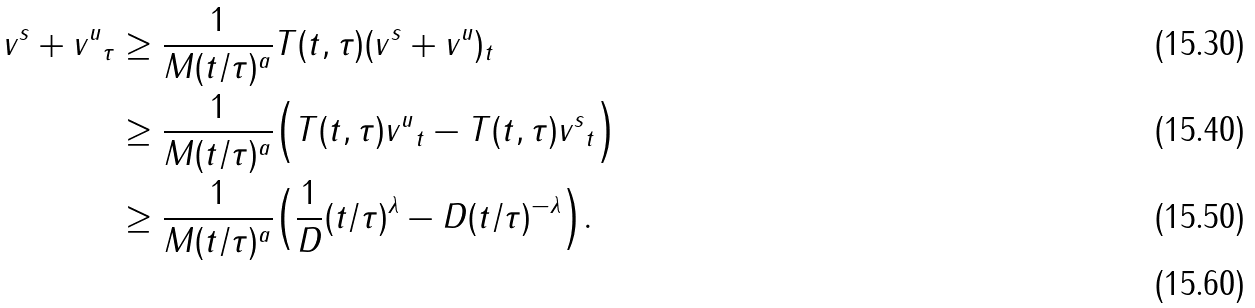<formula> <loc_0><loc_0><loc_500><loc_500>\| v ^ { s } + v ^ { u } \| _ { \tau } & \geq \frac { 1 } { M ( t / \tau ) ^ { a } } \| T ( t , \tau ) ( v ^ { s } + v ^ { u } ) \| _ { t } \\ & \geq \frac { 1 } { M ( t / \tau ) ^ { a } } \Big { ( } \| T ( t , \tau ) v ^ { u } \| _ { t } - \| T ( t , \tau ) v ^ { s } \| _ { t } \Big { ) } \\ & \geq \frac { 1 } { M ( t / \tau ) ^ { a } } \Big { ( } \frac { 1 } { D } ( t / \tau ) ^ { \lambda } - D ( t / \tau ) ^ { - \lambda } \Big { ) } . \\</formula> 